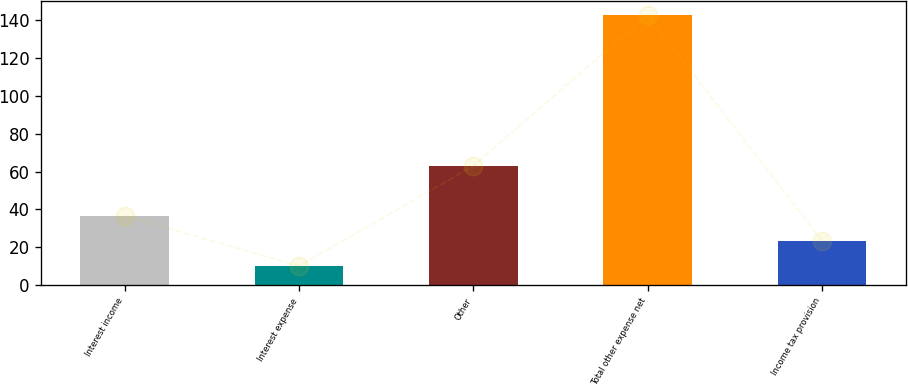<chart> <loc_0><loc_0><loc_500><loc_500><bar_chart><fcel>Interest income<fcel>Interest expense<fcel>Other<fcel>Total other expense net<fcel>Income tax provision<nl><fcel>36.6<fcel>10<fcel>63<fcel>143<fcel>23.3<nl></chart> 